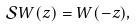<formula> <loc_0><loc_0><loc_500><loc_500>\mathcal { S } W ( z ) = W ( - z ) ,</formula> 